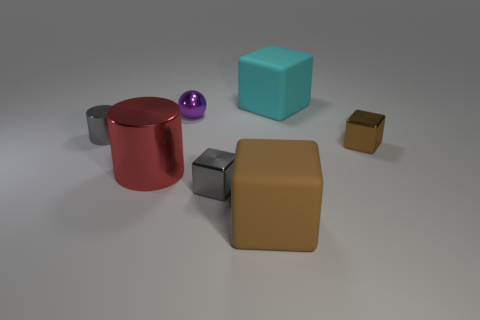Are there any small shiny cubes of the same color as the tiny cylinder?
Provide a succinct answer. Yes. There is a big red cylinder; what number of brown metal cubes are on the left side of it?
Offer a terse response. 0. Are the small thing that is to the right of the large cyan cube and the small purple ball made of the same material?
Your response must be concise. Yes. The other large rubber object that is the same shape as the big cyan matte thing is what color?
Provide a short and direct response. Brown. What shape is the brown matte object?
Your answer should be compact. Cube. How many things are brown metallic cubes or brown matte blocks?
Your response must be concise. 2. Is the color of the small metal object in front of the large metal cylinder the same as the tiny shiny thing on the left side of the metal ball?
Your response must be concise. Yes. How many other things are the same shape as the big cyan rubber thing?
Make the answer very short. 3. Are any brown rubber cubes visible?
Make the answer very short. Yes. What number of objects are small cyan shiny balls or matte blocks that are behind the purple shiny thing?
Provide a succinct answer. 1. 